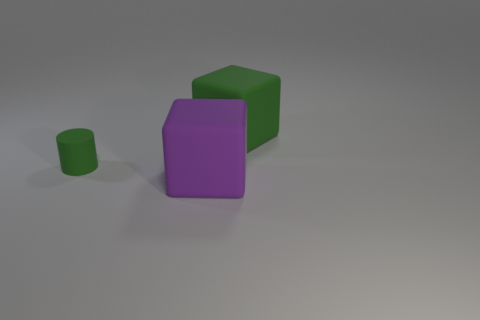Add 1 blocks. How many objects exist? 4 Subtract all green blocks. How many blocks are left? 1 Subtract all blocks. How many objects are left? 1 Subtract 0 cyan blocks. How many objects are left? 3 Subtract all blue cylinders. Subtract all gray blocks. How many cylinders are left? 1 Subtract all red rubber blocks. Subtract all big green cubes. How many objects are left? 2 Add 1 big green matte cubes. How many big green matte cubes are left? 2 Add 1 big green cubes. How many big green cubes exist? 2 